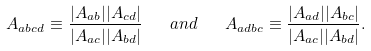<formula> <loc_0><loc_0><loc_500><loc_500>A _ { a b c d } \equiv \frac { | A _ { a b } | | A _ { c d } | } { | A _ { a c } | | A _ { b d } | } \quad a n d \quad A _ { a d b c } \equiv \frac { | A _ { a d } | | A _ { b c } | } { | A _ { a c } | | A _ { b d } | } .</formula> 